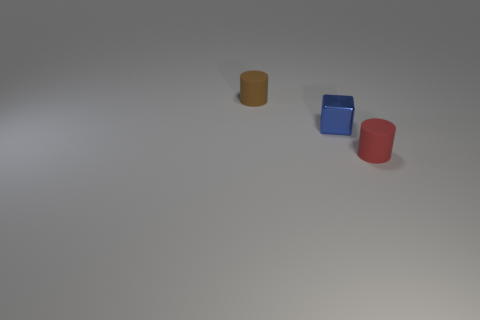How do the shadows give us clues about the lighting direction in this image? The shadows cast by the objects are directed towards the bottom right of the image, indicating that the light source is located towards the top left. This directional lighting creates a soft gradient of shadows and gives a three-dimensional feel to the objects on a relatively neutral background. 